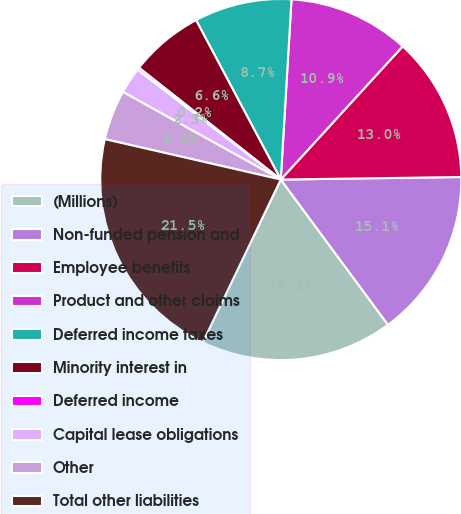<chart> <loc_0><loc_0><loc_500><loc_500><pie_chart><fcel>(Millions)<fcel>Non-funded pension and<fcel>Employee benefits<fcel>Product and other claims<fcel>Deferred income taxes<fcel>Minority interest in<fcel>Deferred income<fcel>Capital lease obligations<fcel>Other<fcel>Total other liabilities<nl><fcel>17.23%<fcel>15.1%<fcel>12.98%<fcel>10.85%<fcel>8.72%<fcel>6.6%<fcel>0.22%<fcel>2.34%<fcel>4.47%<fcel>21.48%<nl></chart> 